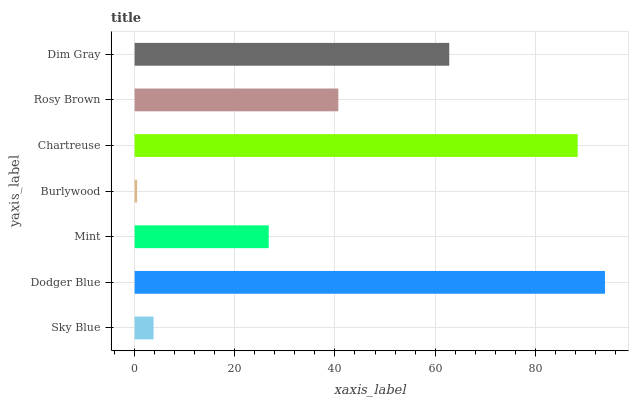Is Burlywood the minimum?
Answer yes or no. Yes. Is Dodger Blue the maximum?
Answer yes or no. Yes. Is Mint the minimum?
Answer yes or no. No. Is Mint the maximum?
Answer yes or no. No. Is Dodger Blue greater than Mint?
Answer yes or no. Yes. Is Mint less than Dodger Blue?
Answer yes or no. Yes. Is Mint greater than Dodger Blue?
Answer yes or no. No. Is Dodger Blue less than Mint?
Answer yes or no. No. Is Rosy Brown the high median?
Answer yes or no. Yes. Is Rosy Brown the low median?
Answer yes or no. Yes. Is Mint the high median?
Answer yes or no. No. Is Sky Blue the low median?
Answer yes or no. No. 